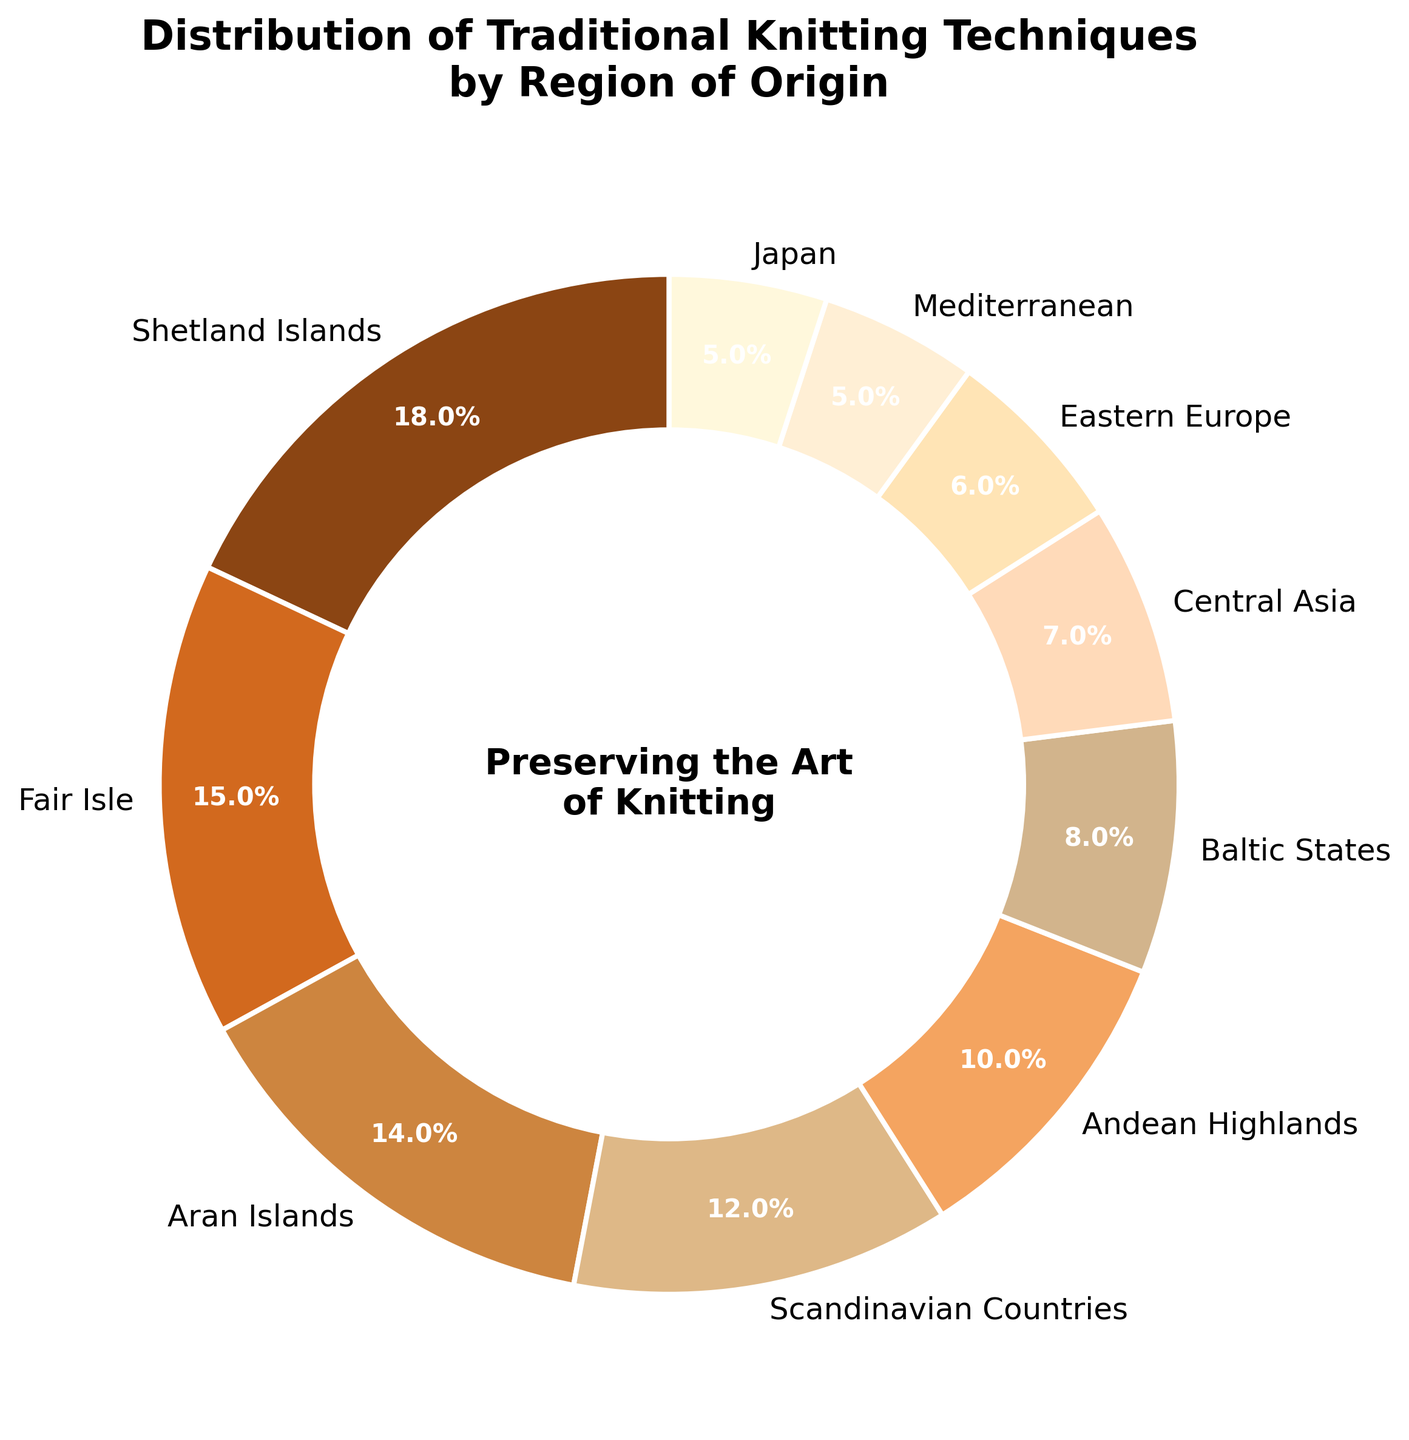Which region has the highest percentage of traditional knitting techniques? The Shetland Islands have the highest percentage. According to the chart, the section indicating the Shetland Islands shows an 18% share, which is the highest.
Answer: Shetland Islands What is the combined percentage of the Aran Islands and Fair Isle regions? The chart shows 15% for Fair Isle and 14% for the Aran Islands. Adding these two percentages gives us 15% + 14% = 29%.
Answer: 29% Which two regions have the smallest percentage share, and what are their percentages? According to the chart, the two regions with the smallest share are the Mediterranean and Japan, each with a 5% share.
Answer: Mediterranean and Japan, both 5% How much higher is the percentage of traditional knitting techniques from the Shetland Islands compared to Central Asia? The percentage for the Shetland Islands is 18%, and for Central Asia, it is 7%. The difference is 18% - 7% = 11%.
Answer: 11% What is the total percentage combined for the Scandinavian Countries, Andean Highlands, and Baltic States? The Scandinavian Countries have 12%, the Andean Highlands have 10%, and the Baltic States have 8%. Summing them gives 12% + 10% + 8% = 30%.
Answer: 30% Which region shows a beige-colored section in the pie chart? The color attributed to the Baltic States in the pie chart is beige.
Answer: Baltic States Is the percentage of traditional knitting techniques in Eastern Europe greater than or equal to 10%? The percentage for Eastern Europe is 6% according to the pie chart. This is less than 10%.
Answer: No What is the median percentage value across all regions? To find the median, list the percentages in order: 5, 5, 6, 7, 8, 10, 12, 14, 15, 18. Since there are 10 values, the median is the average of the 5th and 6th values: (8% + 10%)/2 = 9%.
Answer: 9% Compare the percentage of traditional knitting techniques in the Scandinavian and Baltic States. Which has a higher percentage, and by how much? The Scandinavian Countries have 12% and the Baltic States have 8%. The difference is 12% - 8% = 4%.
Answer: Scandinavian Countries by 4% What is the cumulative percentage of all regions that have less than 10% representation? Regions with less than 10% are Baltic States (8%), Central Asia (7%), Eastern Europe (6%), Mediterranean (5%), and Japan (5%). Adding these gives 8% + 7% + 6% + 5% + 5% = 31%.
Answer: 31% 